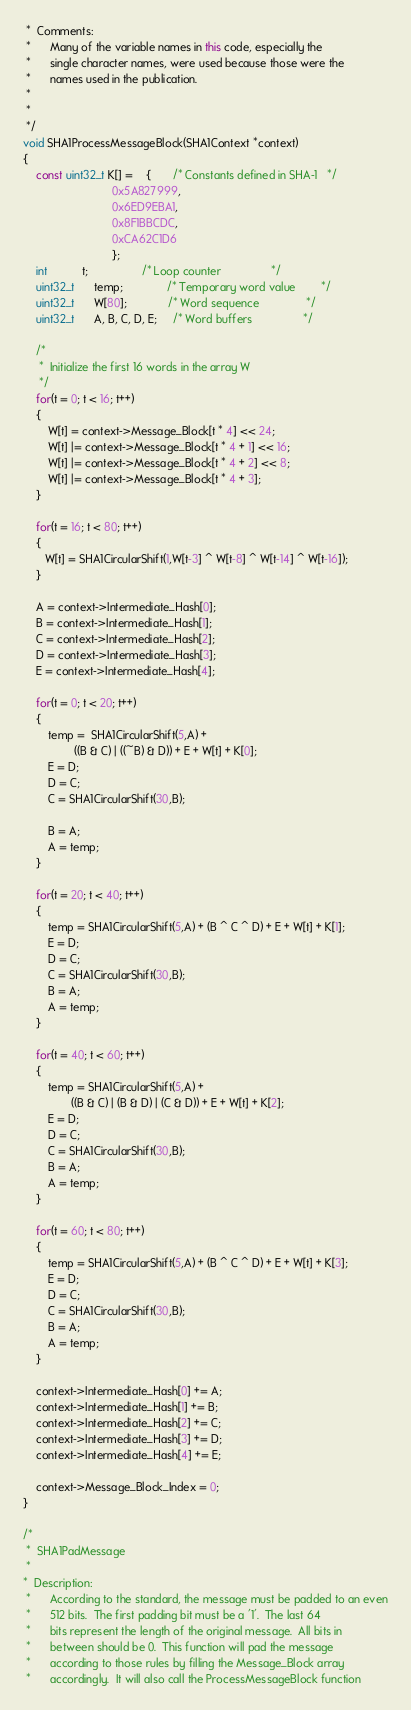<code> <loc_0><loc_0><loc_500><loc_500><_C++_> *  Comments:
 *      Many of the variable names in this code, especially the
 *      single character names, were used because those were the
 *      names used in the publication.
 *
 *
 */
void SHA1ProcessMessageBlock(SHA1Context *context)
{
    const uint32_t K[] =    {       /* Constants defined in SHA-1   */
                            0x5A827999,
                            0x6ED9EBA1,
                            0x8F1BBCDC,
                            0xCA62C1D6
                            };
    int           t;                 /* Loop counter                */
    uint32_t      temp;              /* Temporary word value        */
    uint32_t      W[80];             /* Word sequence               */
    uint32_t      A, B, C, D, E;     /* Word buffers                */

    /*
     *  Initialize the first 16 words in the array W
     */
    for(t = 0; t < 16; t++)
    {
        W[t] = context->Message_Block[t * 4] << 24;
        W[t] |= context->Message_Block[t * 4 + 1] << 16;
        W[t] |= context->Message_Block[t * 4 + 2] << 8;
        W[t] |= context->Message_Block[t * 4 + 3];
    }

    for(t = 16; t < 80; t++)
    {
       W[t] = SHA1CircularShift(1,W[t-3] ^ W[t-8] ^ W[t-14] ^ W[t-16]);
    }

    A = context->Intermediate_Hash[0];
    B = context->Intermediate_Hash[1];
    C = context->Intermediate_Hash[2];
    D = context->Intermediate_Hash[3];
    E = context->Intermediate_Hash[4];

    for(t = 0; t < 20; t++)
    {
        temp =  SHA1CircularShift(5,A) +
                ((B & C) | ((~B) & D)) + E + W[t] + K[0];
        E = D;
        D = C;
        C = SHA1CircularShift(30,B);

        B = A;
        A = temp;
    }

    for(t = 20; t < 40; t++)
    {
        temp = SHA1CircularShift(5,A) + (B ^ C ^ D) + E + W[t] + K[1];
        E = D;
        D = C;
        C = SHA1CircularShift(30,B);
        B = A;
        A = temp;
    }

    for(t = 40; t < 60; t++)
    {
        temp = SHA1CircularShift(5,A) +
               ((B & C) | (B & D) | (C & D)) + E + W[t] + K[2];
        E = D;
        D = C;
        C = SHA1CircularShift(30,B);
        B = A;
        A = temp;
    }

    for(t = 60; t < 80; t++)
    {
        temp = SHA1CircularShift(5,A) + (B ^ C ^ D) + E + W[t] + K[3];
        E = D;
        D = C;
        C = SHA1CircularShift(30,B);
        B = A;
        A = temp;
    }

    context->Intermediate_Hash[0] += A;
    context->Intermediate_Hash[1] += B;
    context->Intermediate_Hash[2] += C;
    context->Intermediate_Hash[3] += D;
    context->Intermediate_Hash[4] += E;

    context->Message_Block_Index = 0;
}

/*
 *  SHA1PadMessage
 *
*  Description:
 *      According to the standard, the message must be padded to an even
 *      512 bits.  The first padding bit must be a '1'.  The last 64
 *      bits represent the length of the original message.  All bits in
 *      between should be 0.  This function will pad the message
 *      according to those rules by filling the Message_Block array
 *      accordingly.  It will also call the ProcessMessageBlock function</code> 